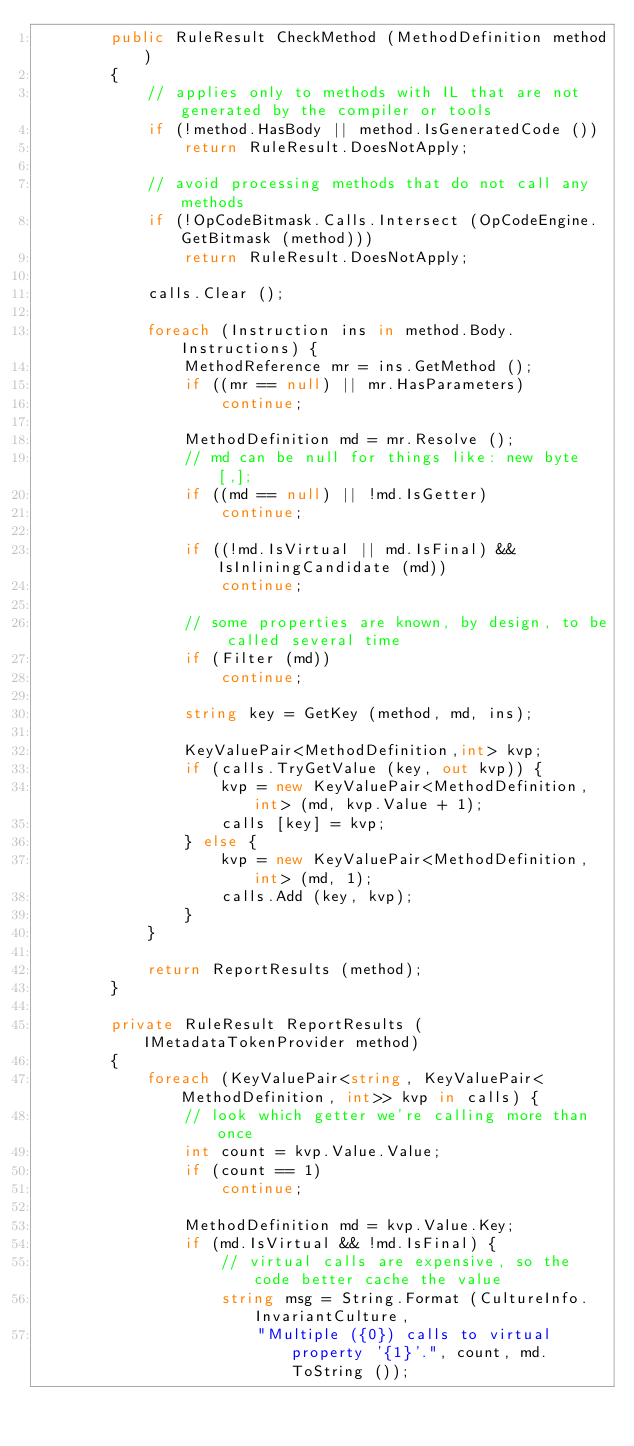<code> <loc_0><loc_0><loc_500><loc_500><_C#_>		public RuleResult CheckMethod (MethodDefinition method)
		{
			// applies only to methods with IL that are not generated by the compiler or tools
			if (!method.HasBody || method.IsGeneratedCode ())
				return RuleResult.DoesNotApply;

			// avoid processing methods that do not call any methods
			if (!OpCodeBitmask.Calls.Intersect (OpCodeEngine.GetBitmask (method)))
				return RuleResult.DoesNotApply;

			calls.Clear ();

			foreach (Instruction ins in method.Body.Instructions) {
				MethodReference mr = ins.GetMethod ();
				if ((mr == null) || mr.HasParameters)
					continue;

				MethodDefinition md = mr.Resolve ();
				// md can be null for things like: new byte[,];
				if ((md == null) || !md.IsGetter)
					continue;

				if ((!md.IsVirtual || md.IsFinal) && IsInliningCandidate (md))
					continue;

				// some properties are known, by design, to be called several time
				if (Filter (md))
					continue;

				string key = GetKey (method, md, ins);

				KeyValuePair<MethodDefinition,int> kvp;
				if (calls.TryGetValue (key, out kvp)) {
					kvp = new KeyValuePair<MethodDefinition, int> (md, kvp.Value + 1);
					calls [key] = kvp;
				} else {
					kvp = new KeyValuePair<MethodDefinition, int> (md, 1);
					calls.Add (key, kvp);
				}
			}

			return ReportResults (method);
		}

		private RuleResult ReportResults (IMetadataTokenProvider method)
		{
			foreach (KeyValuePair<string, KeyValuePair<MethodDefinition, int>> kvp in calls) {
				// look which getter we're calling more than once
				int count = kvp.Value.Value;
				if (count == 1)
					continue;

				MethodDefinition md = kvp.Value.Key;
				if (md.IsVirtual && !md.IsFinal) {
					// virtual calls are expensive, so the code better cache the value
					string msg = String.Format (CultureInfo.InvariantCulture, 
						"Multiple ({0}) calls to virtual property '{1}'.", count, md.ToString ());</code> 